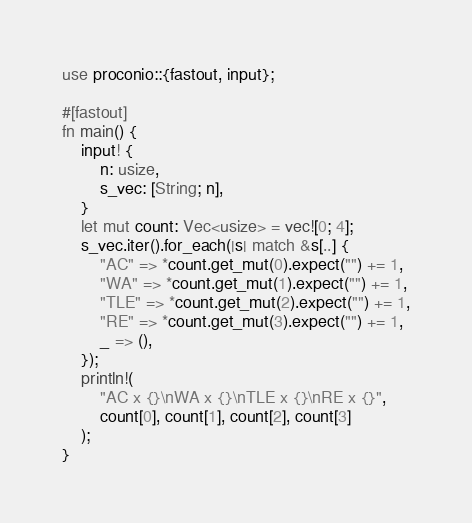Convert code to text. <code><loc_0><loc_0><loc_500><loc_500><_Rust_>use proconio::{fastout, input};

#[fastout]
fn main() {
    input! {
        n: usize,
        s_vec: [String; n],
    }
    let mut count: Vec<usize> = vec![0; 4];
    s_vec.iter().for_each(|s| match &s[..] {
        "AC" => *count.get_mut(0).expect("") += 1,
        "WA" => *count.get_mut(1).expect("") += 1,
        "TLE" => *count.get_mut(2).expect("") += 1,
        "RE" => *count.get_mut(3).expect("") += 1,
        _ => (),
    });
    println!(
        "AC x {}\nWA x {}\nTLE x {}\nRE x {}",
        count[0], count[1], count[2], count[3]
    );
}
</code> 